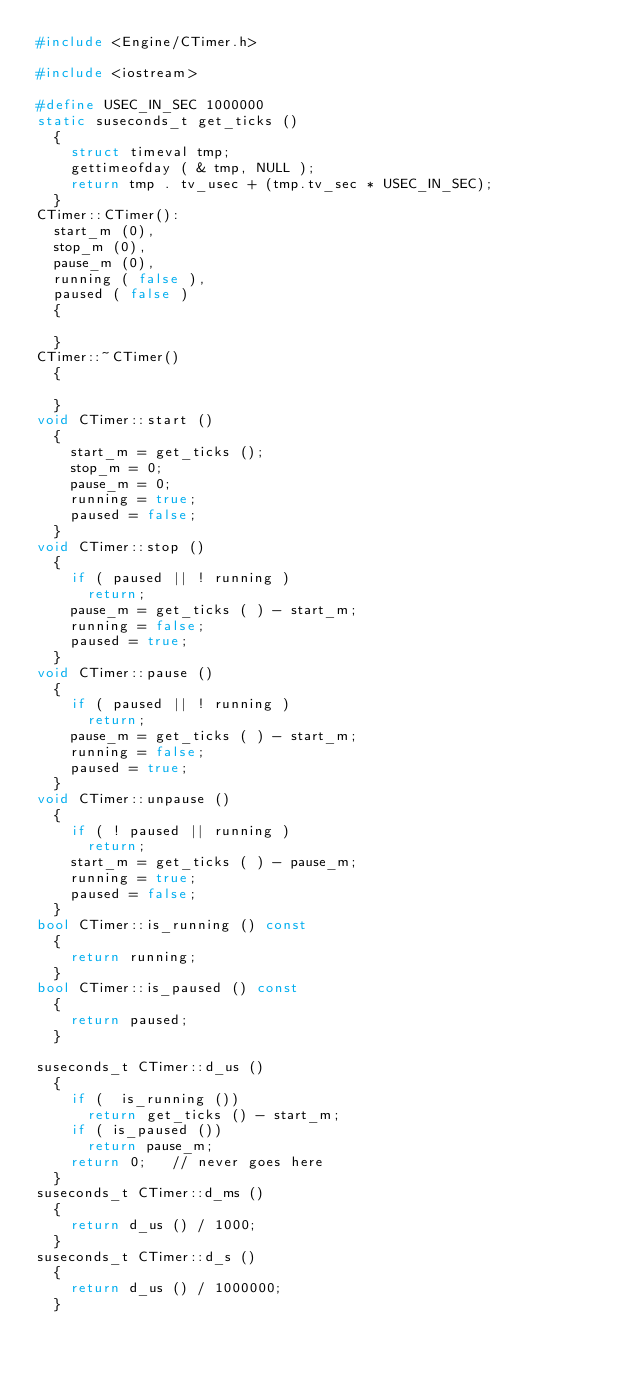Convert code to text. <code><loc_0><loc_0><loc_500><loc_500><_C++_>#include <Engine/CTimer.h>

#include <iostream>	

#define USEC_IN_SEC 1000000
static suseconds_t get_ticks ()
	{
		struct timeval tmp;
		gettimeofday ( & tmp, NULL );
		return tmp . tv_usec + (tmp.tv_sec * USEC_IN_SEC);
	}
CTimer::CTimer():
	start_m (0),
	stop_m (0),
	pause_m (0),
	running ( false ),
	paused ( false )
	{

	}
CTimer::~CTimer()
	{

	}
void CTimer::start ()
	{
		start_m = get_ticks ();
		stop_m = 0;
		pause_m = 0;
		running = true;
		paused = false;
	}
void CTimer::stop ()
	{
		if ( paused || ! running )
			return;
		pause_m = get_ticks ( ) - start_m;
		running = false;
		paused = true;
	}
void CTimer::pause ()
	{
		if ( paused || ! running )
			return;
		pause_m = get_ticks ( ) - start_m;
		running = false;
		paused = true;
	}
void CTimer::unpause ()
	{
		if ( ! paused || running )
			return;
		start_m = get_ticks ( ) - pause_m;
		running = true;
		paused = false;
	}
bool CTimer::is_running () const
	{
		return running;
	}
bool CTimer::is_paused () const
	{
		return paused;
	}

suseconds_t CTimer::d_us ()
	{
		if (  is_running ())
			return get_ticks () - start_m;
		if ( is_paused ())
			return pause_m;
		return 0;   // never goes here
	}
suseconds_t CTimer::d_ms ()
	{
		return d_us () / 1000;
	}
suseconds_t CTimer::d_s ()
	{
		return d_us () / 1000000;
	}
</code> 